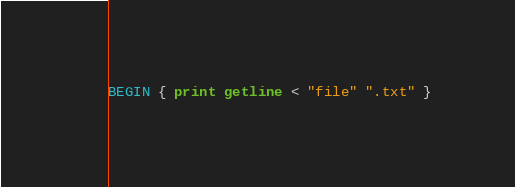Convert code to text. <code><loc_0><loc_0><loc_500><loc_500><_Awk_>BEGIN { print getline < "file" ".txt" }
</code> 